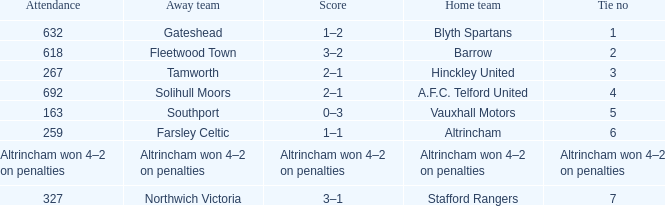Which domestic team experienced 2 ties? Barrow. 